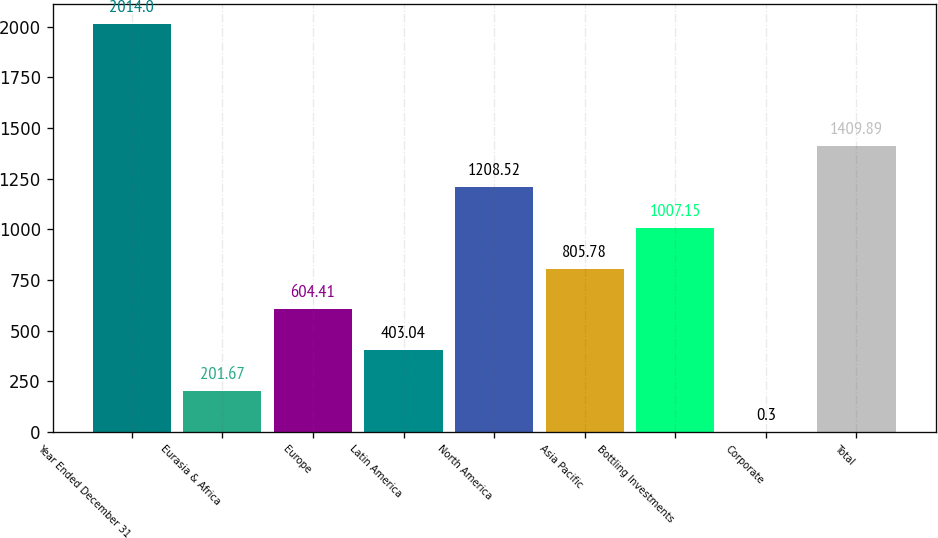<chart> <loc_0><loc_0><loc_500><loc_500><bar_chart><fcel>Year Ended December 31<fcel>Eurasia & Africa<fcel>Europe<fcel>Latin America<fcel>North America<fcel>Asia Pacific<fcel>Bottling Investments<fcel>Corporate<fcel>Total<nl><fcel>2014<fcel>201.67<fcel>604.41<fcel>403.04<fcel>1208.52<fcel>805.78<fcel>1007.15<fcel>0.3<fcel>1409.89<nl></chart> 